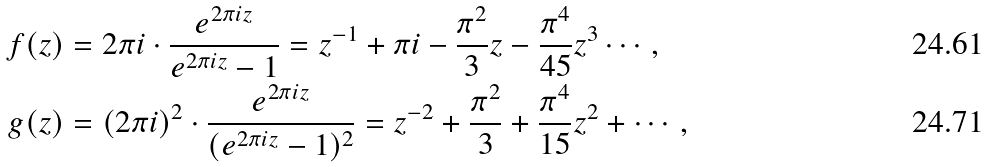<formula> <loc_0><loc_0><loc_500><loc_500>f ( z ) & = 2 \pi i \cdot \frac { e ^ { 2 \pi i z } } { e ^ { 2 \pi i z } - 1 } = z ^ { - 1 } + \pi i - \frac { \pi ^ { 2 } } { 3 } z - \frac { \pi ^ { 4 } } { 4 5 } z ^ { 3 } \cdots , \\ g ( z ) & = ( 2 \pi i ) ^ { 2 } \cdot \frac { e ^ { 2 \pi i z } } { ( e ^ { 2 \pi i z } - 1 ) ^ { 2 } } = z ^ { - 2 } + \frac { \pi ^ { 2 } } { 3 } + \frac { \pi ^ { 4 } } { 1 5 } z ^ { 2 } + \cdots ,</formula> 